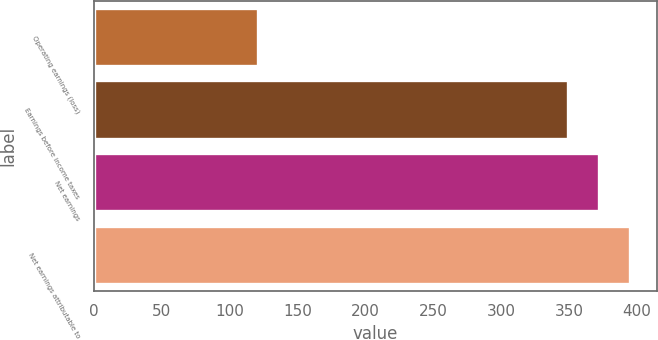Convert chart. <chart><loc_0><loc_0><loc_500><loc_500><bar_chart><fcel>Operating earnings (loss)<fcel>Earnings before income taxes<fcel>Net earnings<fcel>Net earnings attributable to<nl><fcel>121.2<fcel>349.2<fcel>372<fcel>394.8<nl></chart> 